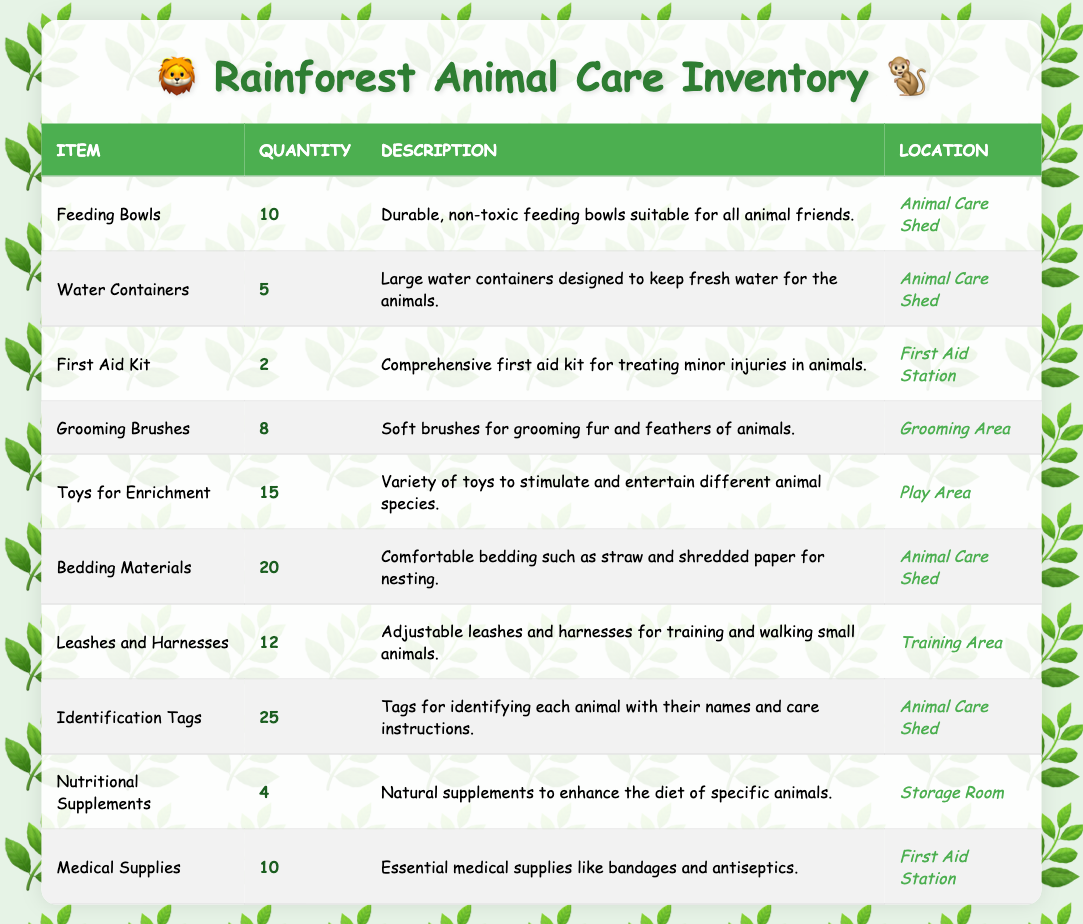What is the total quantity of Feeding Bowls and Water Containers? To find the total quantity, we need to add the quantities of Feeding Bowls, which is 10, and Water Containers, which is 5. Therefore, 10 + 5 = 15.
Answer: 15 How many items are stored in the Animal Care Shed? There are five items stored in the Animal Care Shed: Feeding Bowls (10), Water Containers (5), Bedding Materials (20), Identification Tags (25), and the total sum is 10 + 5 + 20 + 25 = 60.
Answer: 60 Is there a First Aid Kit available in the Grooming Area? According to the table, the First Aid Kit is located at the First Aid Station, not in the Grooming Area. Thus, the statement is false.
Answer: No How many more Toys for Enrichment are there than Nutritional Supplements? We find the quantity of Toys for Enrichment, which is 15, and the quantity of Nutritional Supplements, which is 4. To find the difference, we calculate 15 - 4 = 11.
Answer: 11 Which item has the highest quantity? To find the item with the highest quantity, we can compare all quantities listed. The item with the highest quantity is Identification Tags, with a total of 25.
Answer: Identification Tags Are there more Grooming Brushes than First Aid Kits? The quantity of Grooming Brushes is 8, and the quantity of First Aid Kits is 2. Since 8 is greater than 2, the statement is true.
Answer: Yes What is the combined quantity of Leashes and Harnesses and Medical Supplies? We find the quantity of Leashes and Harnesses, which is 12, and Medical Supplies, which is 10. Now we add them: 12 + 10 = 22.
Answer: 22 Do we have any items with less than 5 in quantity? Checking the quantities in the table, we see that Nutritional Supplements have a quantity of 4, which is less than 5. Therefore, there is at least one item that meets this criterion.
Answer: Yes How many more total items are there in the Animal Care Shed compared to the First Aid Station? The total quantity of items in the Animal Care Shed is 60 (as calculated previously). In the First Aid Station, the quantities are First Aid Kits (2) and Medical Supplies (10), totaling 12. The difference is then 60 - 12 = 48.
Answer: 48 